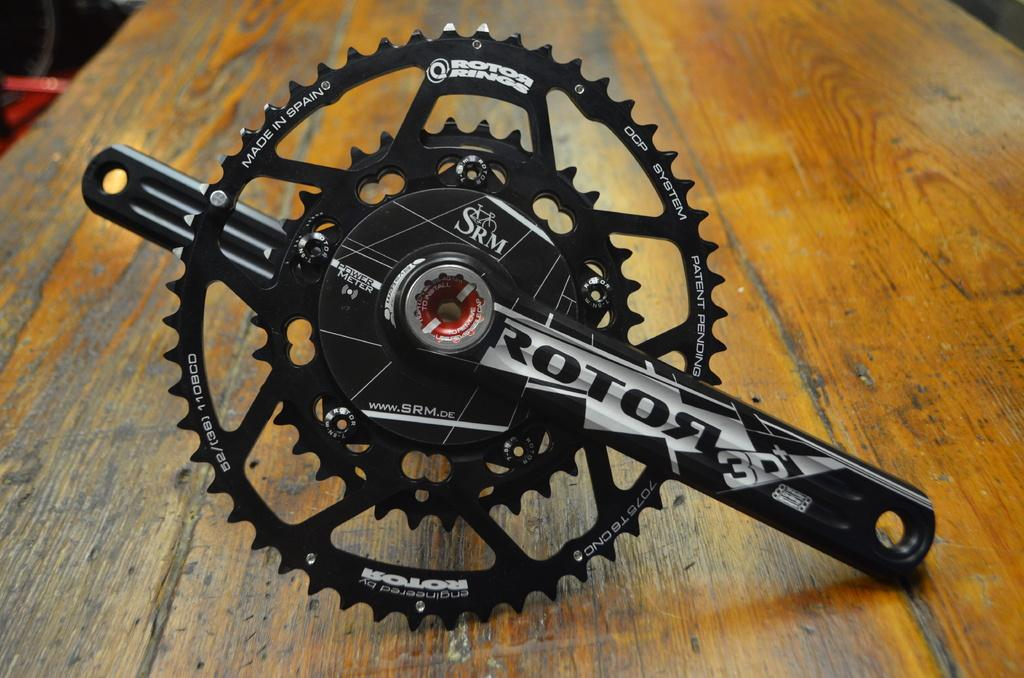What type of furniture is present in the image? There is a table in the image. What object is located in the middle of the table? There is a metal instrument in the middle of the table. What type of fear is depicted in the image? There is no depiction of fear in the image; it only features a table with a metal instrument in the middle. 